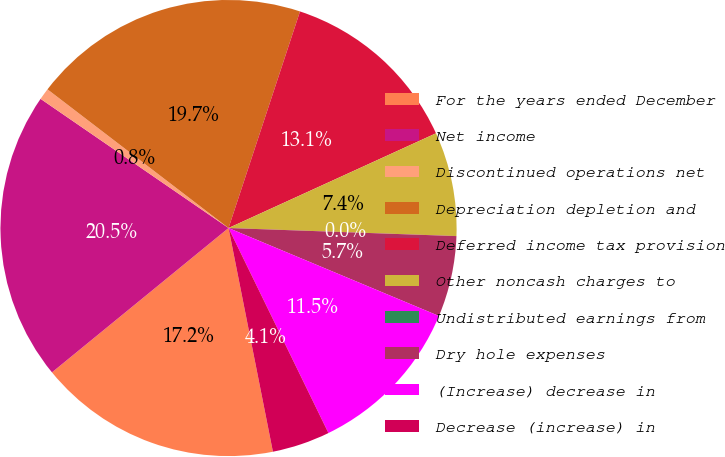<chart> <loc_0><loc_0><loc_500><loc_500><pie_chart><fcel>For the years ended December<fcel>Net income<fcel>Discontinued operations net<fcel>Depreciation depletion and<fcel>Deferred income tax provision<fcel>Other noncash charges to<fcel>Undistributed earnings from<fcel>Dry hole expenses<fcel>(Increase) decrease in<fcel>Decrease (increase) in<nl><fcel>17.21%<fcel>20.49%<fcel>0.82%<fcel>19.67%<fcel>13.11%<fcel>7.38%<fcel>0.0%<fcel>5.74%<fcel>11.48%<fcel>4.1%<nl></chart> 